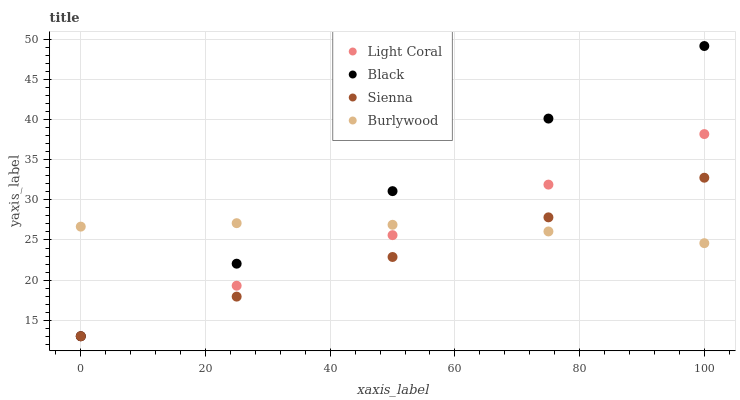Does Sienna have the minimum area under the curve?
Answer yes or no. Yes. Does Black have the maximum area under the curve?
Answer yes or no. Yes. Does Black have the minimum area under the curve?
Answer yes or no. No. Does Sienna have the maximum area under the curve?
Answer yes or no. No. Is Sienna the smoothest?
Answer yes or no. Yes. Is Burlywood the roughest?
Answer yes or no. Yes. Is Black the smoothest?
Answer yes or no. No. Is Black the roughest?
Answer yes or no. No. Does Light Coral have the lowest value?
Answer yes or no. Yes. Does Burlywood have the lowest value?
Answer yes or no. No. Does Black have the highest value?
Answer yes or no. Yes. Does Sienna have the highest value?
Answer yes or no. No. Does Burlywood intersect Sienna?
Answer yes or no. Yes. Is Burlywood less than Sienna?
Answer yes or no. No. Is Burlywood greater than Sienna?
Answer yes or no. No. 